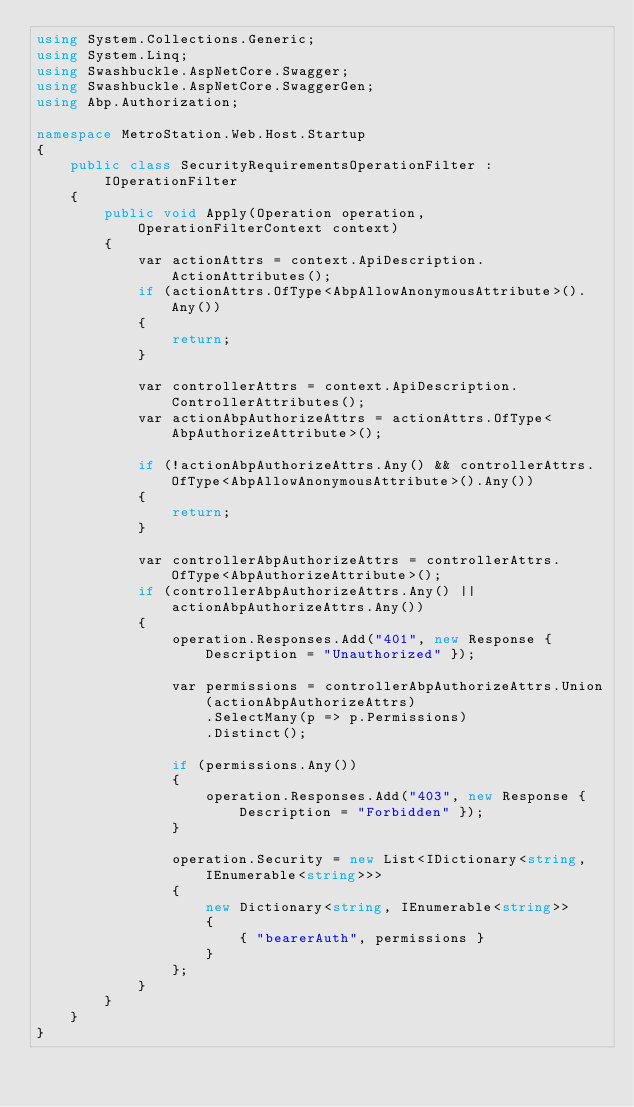<code> <loc_0><loc_0><loc_500><loc_500><_C#_>using System.Collections.Generic;
using System.Linq;
using Swashbuckle.AspNetCore.Swagger;
using Swashbuckle.AspNetCore.SwaggerGen;
using Abp.Authorization;

namespace MetroStation.Web.Host.Startup
{
    public class SecurityRequirementsOperationFilter : IOperationFilter
    {
        public void Apply(Operation operation, OperationFilterContext context)
        {
            var actionAttrs = context.ApiDescription.ActionAttributes();
            if (actionAttrs.OfType<AbpAllowAnonymousAttribute>().Any())
            {
                return;
            }

            var controllerAttrs = context.ApiDescription.ControllerAttributes();
            var actionAbpAuthorizeAttrs = actionAttrs.OfType<AbpAuthorizeAttribute>();

            if (!actionAbpAuthorizeAttrs.Any() && controllerAttrs.OfType<AbpAllowAnonymousAttribute>().Any())
            {
                return;
            }

            var controllerAbpAuthorizeAttrs = controllerAttrs.OfType<AbpAuthorizeAttribute>();
            if (controllerAbpAuthorizeAttrs.Any() || actionAbpAuthorizeAttrs.Any())
            {
                operation.Responses.Add("401", new Response { Description = "Unauthorized" });

                var permissions = controllerAbpAuthorizeAttrs.Union(actionAbpAuthorizeAttrs)
                    .SelectMany(p => p.Permissions)
                    .Distinct();

                if (permissions.Any())
                {
                    operation.Responses.Add("403", new Response { Description = "Forbidden" });
                }

                operation.Security = new List<IDictionary<string, IEnumerable<string>>>
                {
                    new Dictionary<string, IEnumerable<string>>
                    {
                        { "bearerAuth", permissions }
                    }
                };
            }
        }
    }
}
</code> 